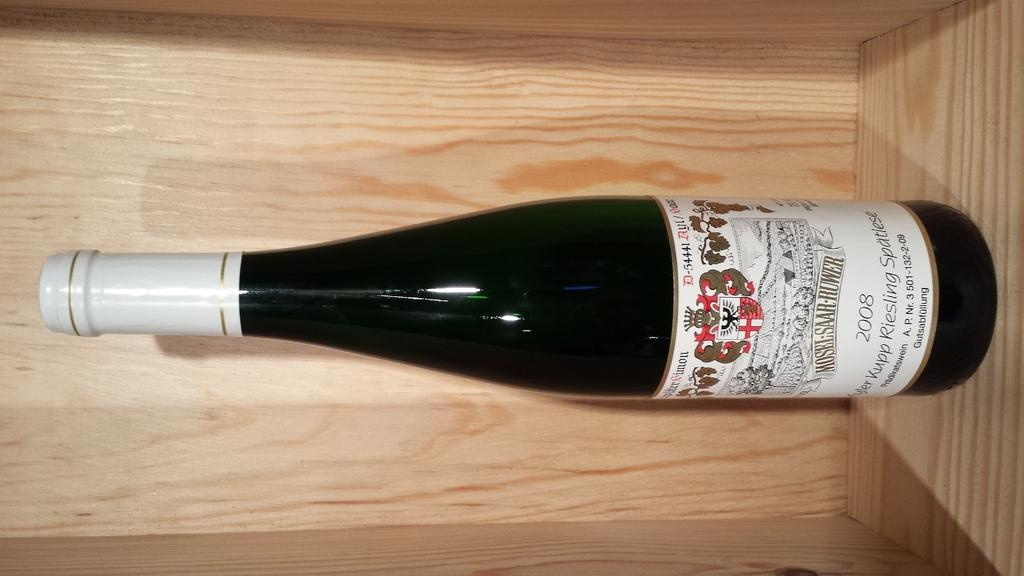<image>
Describe the image concisely. A bottle of riesling from 2008 sits in a wooden crate. 